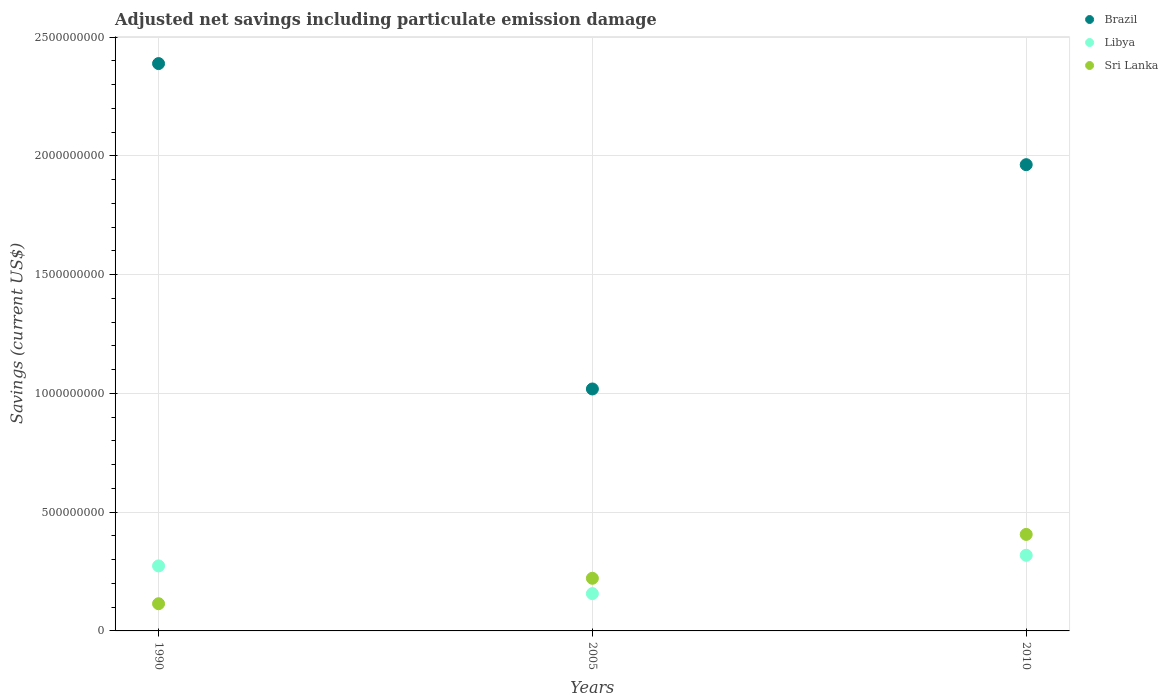Is the number of dotlines equal to the number of legend labels?
Ensure brevity in your answer.  Yes. What is the net savings in Sri Lanka in 1990?
Keep it short and to the point. 1.15e+08. Across all years, what is the maximum net savings in Brazil?
Keep it short and to the point. 2.39e+09. Across all years, what is the minimum net savings in Sri Lanka?
Provide a short and direct response. 1.15e+08. In which year was the net savings in Sri Lanka minimum?
Your answer should be very brief. 1990. What is the total net savings in Libya in the graph?
Your response must be concise. 7.49e+08. What is the difference between the net savings in Sri Lanka in 1990 and that in 2005?
Your response must be concise. -1.07e+08. What is the difference between the net savings in Libya in 1990 and the net savings in Sri Lanka in 2005?
Your answer should be very brief. 5.21e+07. What is the average net savings in Brazil per year?
Make the answer very short. 1.79e+09. In the year 2005, what is the difference between the net savings in Libya and net savings in Sri Lanka?
Your response must be concise. -6.46e+07. What is the ratio of the net savings in Brazil in 1990 to that in 2010?
Offer a very short reply. 1.22. What is the difference between the highest and the second highest net savings in Sri Lanka?
Give a very brief answer. 1.85e+08. What is the difference between the highest and the lowest net savings in Libya?
Give a very brief answer. 1.61e+08. In how many years, is the net savings in Sri Lanka greater than the average net savings in Sri Lanka taken over all years?
Your answer should be compact. 1. Is it the case that in every year, the sum of the net savings in Brazil and net savings in Sri Lanka  is greater than the net savings in Libya?
Offer a terse response. Yes. Does the net savings in Sri Lanka monotonically increase over the years?
Keep it short and to the point. Yes. Is the net savings in Libya strictly greater than the net savings in Brazil over the years?
Give a very brief answer. No. Where does the legend appear in the graph?
Offer a terse response. Top right. How many legend labels are there?
Offer a terse response. 3. What is the title of the graph?
Offer a terse response. Adjusted net savings including particulate emission damage. What is the label or title of the X-axis?
Provide a succinct answer. Years. What is the label or title of the Y-axis?
Offer a very short reply. Savings (current US$). What is the Savings (current US$) of Brazil in 1990?
Keep it short and to the point. 2.39e+09. What is the Savings (current US$) in Libya in 1990?
Make the answer very short. 2.74e+08. What is the Savings (current US$) of Sri Lanka in 1990?
Keep it short and to the point. 1.15e+08. What is the Savings (current US$) of Brazil in 2005?
Offer a very short reply. 1.02e+09. What is the Savings (current US$) of Libya in 2005?
Keep it short and to the point. 1.57e+08. What is the Savings (current US$) of Sri Lanka in 2005?
Offer a terse response. 2.22e+08. What is the Savings (current US$) in Brazil in 2010?
Your answer should be compact. 1.96e+09. What is the Savings (current US$) in Libya in 2010?
Make the answer very short. 3.18e+08. What is the Savings (current US$) of Sri Lanka in 2010?
Offer a very short reply. 4.06e+08. Across all years, what is the maximum Savings (current US$) of Brazil?
Your answer should be compact. 2.39e+09. Across all years, what is the maximum Savings (current US$) in Libya?
Your response must be concise. 3.18e+08. Across all years, what is the maximum Savings (current US$) in Sri Lanka?
Your response must be concise. 4.06e+08. Across all years, what is the minimum Savings (current US$) of Brazil?
Keep it short and to the point. 1.02e+09. Across all years, what is the minimum Savings (current US$) in Libya?
Provide a short and direct response. 1.57e+08. Across all years, what is the minimum Savings (current US$) in Sri Lanka?
Offer a very short reply. 1.15e+08. What is the total Savings (current US$) in Brazil in the graph?
Give a very brief answer. 5.37e+09. What is the total Savings (current US$) in Libya in the graph?
Give a very brief answer. 7.49e+08. What is the total Savings (current US$) in Sri Lanka in the graph?
Your answer should be compact. 7.42e+08. What is the difference between the Savings (current US$) of Brazil in 1990 and that in 2005?
Your answer should be very brief. 1.37e+09. What is the difference between the Savings (current US$) in Libya in 1990 and that in 2005?
Make the answer very short. 1.17e+08. What is the difference between the Savings (current US$) of Sri Lanka in 1990 and that in 2005?
Your response must be concise. -1.07e+08. What is the difference between the Savings (current US$) in Brazil in 1990 and that in 2010?
Offer a very short reply. 4.26e+08. What is the difference between the Savings (current US$) of Libya in 1990 and that in 2010?
Make the answer very short. -4.47e+07. What is the difference between the Savings (current US$) of Sri Lanka in 1990 and that in 2010?
Offer a terse response. -2.92e+08. What is the difference between the Savings (current US$) of Brazil in 2005 and that in 2010?
Give a very brief answer. -9.44e+08. What is the difference between the Savings (current US$) in Libya in 2005 and that in 2010?
Provide a succinct answer. -1.61e+08. What is the difference between the Savings (current US$) in Sri Lanka in 2005 and that in 2010?
Provide a succinct answer. -1.85e+08. What is the difference between the Savings (current US$) in Brazil in 1990 and the Savings (current US$) in Libya in 2005?
Give a very brief answer. 2.23e+09. What is the difference between the Savings (current US$) in Brazil in 1990 and the Savings (current US$) in Sri Lanka in 2005?
Your response must be concise. 2.17e+09. What is the difference between the Savings (current US$) of Libya in 1990 and the Savings (current US$) of Sri Lanka in 2005?
Your response must be concise. 5.21e+07. What is the difference between the Savings (current US$) of Brazil in 1990 and the Savings (current US$) of Libya in 2010?
Your response must be concise. 2.07e+09. What is the difference between the Savings (current US$) in Brazil in 1990 and the Savings (current US$) in Sri Lanka in 2010?
Your answer should be compact. 1.98e+09. What is the difference between the Savings (current US$) of Libya in 1990 and the Savings (current US$) of Sri Lanka in 2010?
Give a very brief answer. -1.33e+08. What is the difference between the Savings (current US$) in Brazil in 2005 and the Savings (current US$) in Libya in 2010?
Provide a succinct answer. 7.00e+08. What is the difference between the Savings (current US$) of Brazil in 2005 and the Savings (current US$) of Sri Lanka in 2010?
Give a very brief answer. 6.12e+08. What is the difference between the Savings (current US$) in Libya in 2005 and the Savings (current US$) in Sri Lanka in 2010?
Your response must be concise. -2.49e+08. What is the average Savings (current US$) in Brazil per year?
Offer a very short reply. 1.79e+09. What is the average Savings (current US$) of Libya per year?
Your response must be concise. 2.50e+08. What is the average Savings (current US$) of Sri Lanka per year?
Provide a short and direct response. 2.47e+08. In the year 1990, what is the difference between the Savings (current US$) of Brazil and Savings (current US$) of Libya?
Provide a succinct answer. 2.11e+09. In the year 1990, what is the difference between the Savings (current US$) in Brazil and Savings (current US$) in Sri Lanka?
Ensure brevity in your answer.  2.27e+09. In the year 1990, what is the difference between the Savings (current US$) in Libya and Savings (current US$) in Sri Lanka?
Give a very brief answer. 1.59e+08. In the year 2005, what is the difference between the Savings (current US$) of Brazil and Savings (current US$) of Libya?
Your answer should be compact. 8.62e+08. In the year 2005, what is the difference between the Savings (current US$) of Brazil and Savings (current US$) of Sri Lanka?
Your answer should be very brief. 7.97e+08. In the year 2005, what is the difference between the Savings (current US$) of Libya and Savings (current US$) of Sri Lanka?
Your answer should be very brief. -6.46e+07. In the year 2010, what is the difference between the Savings (current US$) in Brazil and Savings (current US$) in Libya?
Provide a succinct answer. 1.64e+09. In the year 2010, what is the difference between the Savings (current US$) of Brazil and Savings (current US$) of Sri Lanka?
Your response must be concise. 1.56e+09. In the year 2010, what is the difference between the Savings (current US$) in Libya and Savings (current US$) in Sri Lanka?
Your answer should be compact. -8.79e+07. What is the ratio of the Savings (current US$) in Brazil in 1990 to that in 2005?
Make the answer very short. 2.34. What is the ratio of the Savings (current US$) in Libya in 1990 to that in 2005?
Ensure brevity in your answer.  1.74. What is the ratio of the Savings (current US$) of Sri Lanka in 1990 to that in 2005?
Ensure brevity in your answer.  0.52. What is the ratio of the Savings (current US$) in Brazil in 1990 to that in 2010?
Your response must be concise. 1.22. What is the ratio of the Savings (current US$) of Libya in 1990 to that in 2010?
Your response must be concise. 0.86. What is the ratio of the Savings (current US$) of Sri Lanka in 1990 to that in 2010?
Your response must be concise. 0.28. What is the ratio of the Savings (current US$) in Brazil in 2005 to that in 2010?
Provide a short and direct response. 0.52. What is the ratio of the Savings (current US$) of Libya in 2005 to that in 2010?
Give a very brief answer. 0.49. What is the ratio of the Savings (current US$) in Sri Lanka in 2005 to that in 2010?
Provide a succinct answer. 0.55. What is the difference between the highest and the second highest Savings (current US$) in Brazil?
Offer a very short reply. 4.26e+08. What is the difference between the highest and the second highest Savings (current US$) of Libya?
Your answer should be compact. 4.47e+07. What is the difference between the highest and the second highest Savings (current US$) of Sri Lanka?
Give a very brief answer. 1.85e+08. What is the difference between the highest and the lowest Savings (current US$) in Brazil?
Your answer should be compact. 1.37e+09. What is the difference between the highest and the lowest Savings (current US$) of Libya?
Give a very brief answer. 1.61e+08. What is the difference between the highest and the lowest Savings (current US$) of Sri Lanka?
Your answer should be very brief. 2.92e+08. 